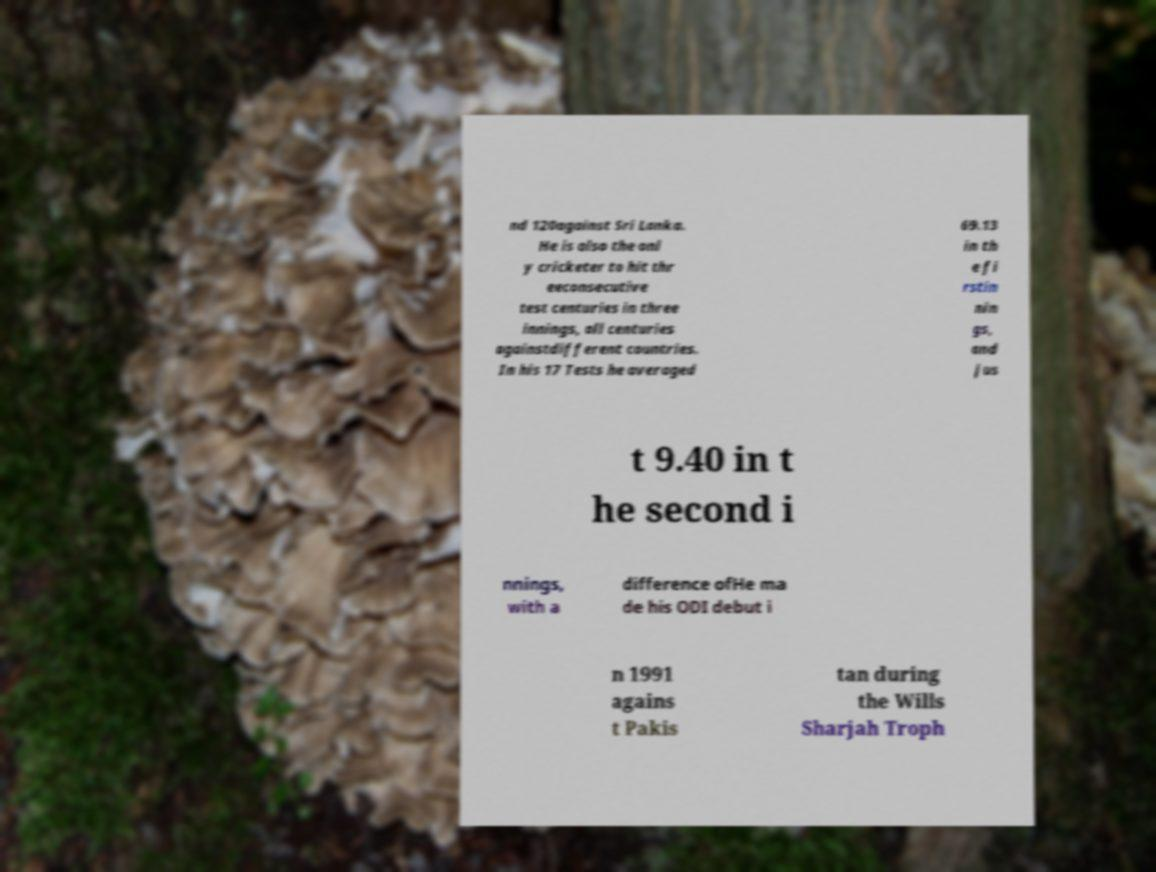There's text embedded in this image that I need extracted. Can you transcribe it verbatim? nd 120against Sri Lanka. He is also the onl y cricketer to hit thr eeconsecutive test centuries in three innings, all centuries againstdifferent countries. In his 17 Tests he averaged 69.13 in th e fi rstin nin gs, and jus t 9.40 in t he second i nnings, with a difference ofHe ma de his ODI debut i n 1991 agains t Pakis tan during the Wills Sharjah Troph 